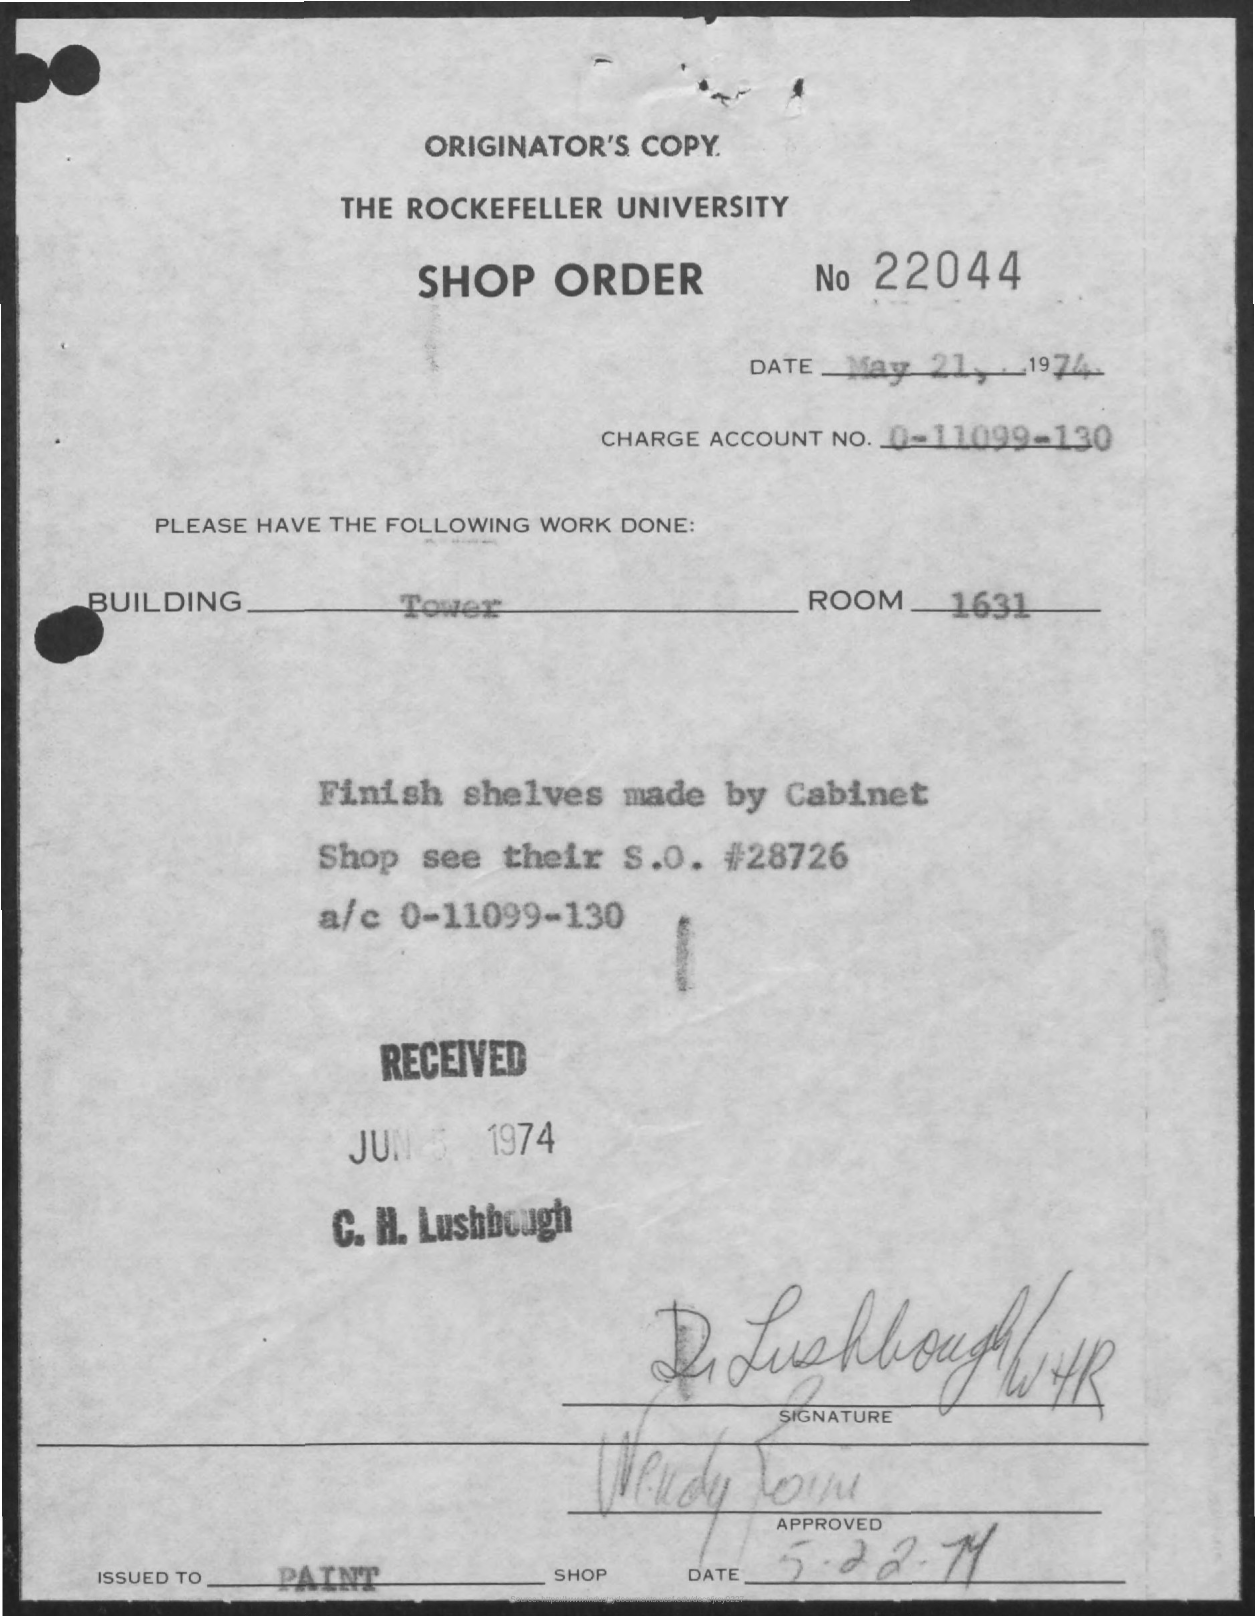Highlight a few significant elements in this photo. The Shop order number is 22044. The received date mentioned in the document is June 5, 1974. The charge account number is a unique identifier that consists of 12 digits, ranging from 0 to 11099-130. The room number is 1631. The type of building is a tower. 